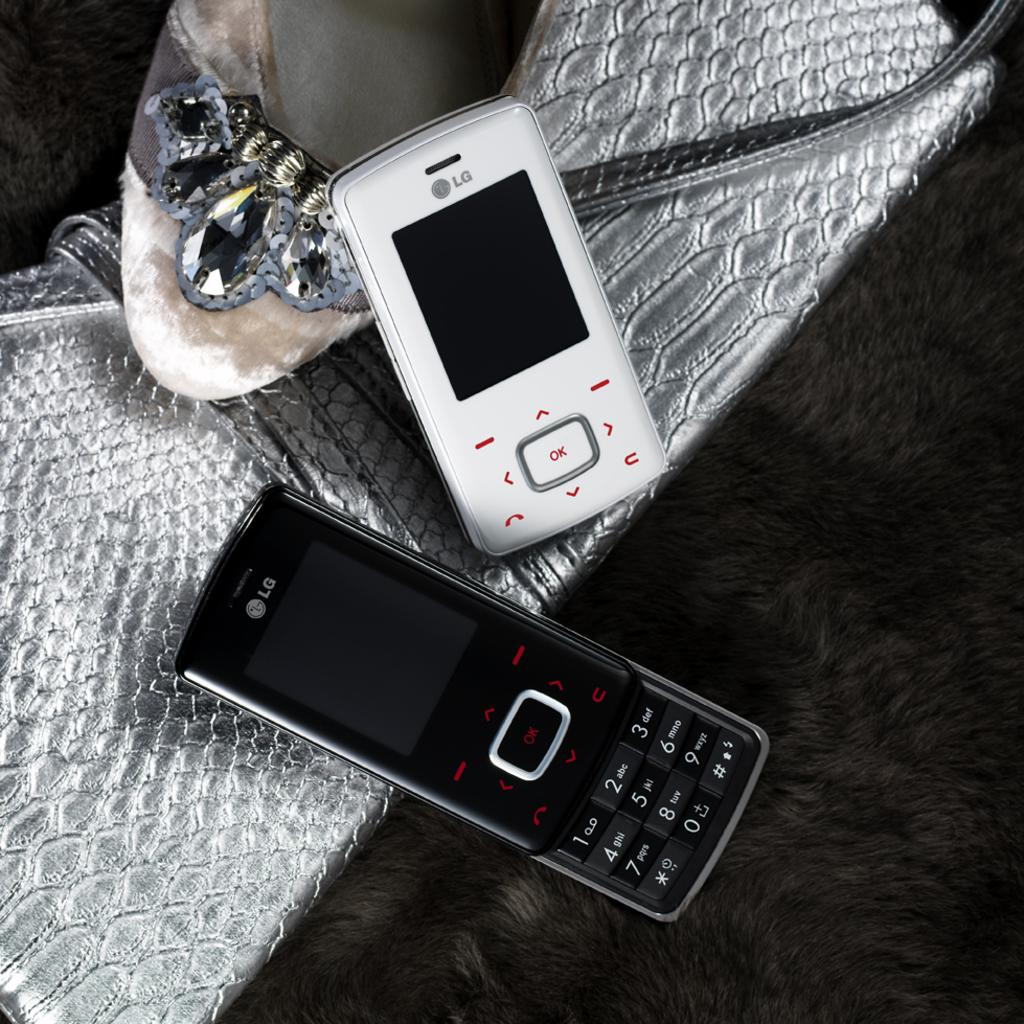What electronic devices can be seen in the image? There are two mobile phones in the image. What type of accessory is present in the image? There is a handbag in the image. What type of personal item is visible in the image? There is footwear in the image. What type of mint can be seen growing on the floor in the image? There is no mint or floor visible in the image; the provided facts only mention mobile phones, a handbag, and footwear. 